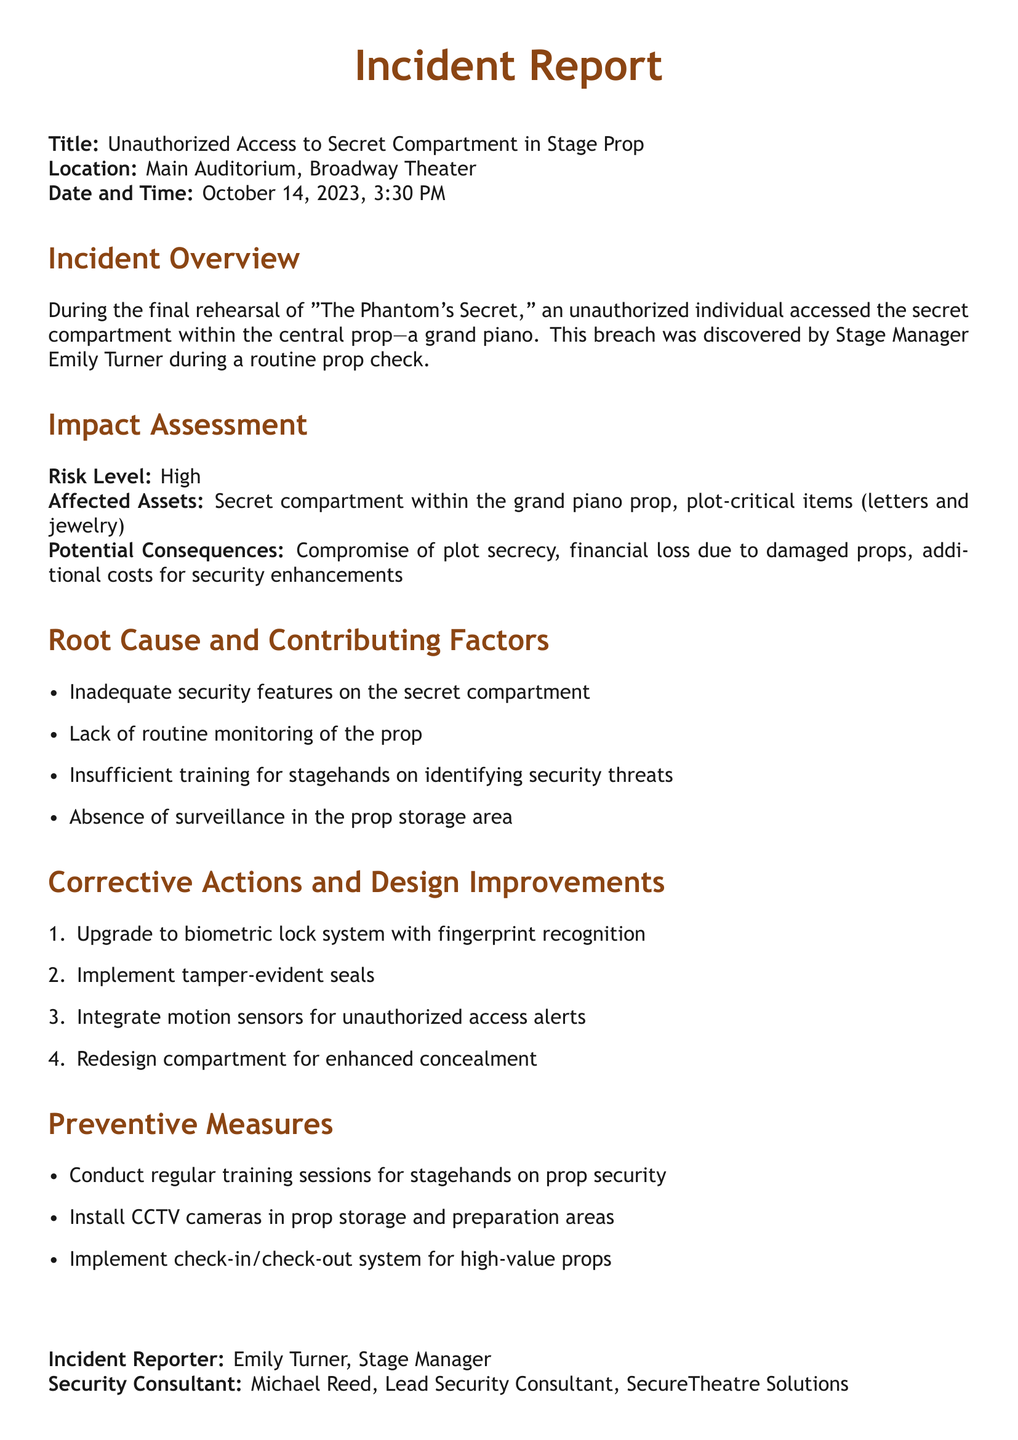what is the title of the incident report? The title of the incident report is mentioned at the top of the document.
Answer: Unauthorized Access to Secret Compartment in Stage Prop who discovered the breach? The incident report specifies that the breach was discovered by the Stage Manager during a routine check.
Answer: Emily Turner what was the location of the incident? The report provides the specific location where the incident occurred.
Answer: Main Auditorium, Broadway Theater what event was taking place during the incident? The document mentions an event associated with the timing of the incident.
Answer: "The Phantom's Secret" what is the risk level assigned to the incident? The report indicates the assessed risk level for the incident.
Answer: High what are two potential consequences mentioned in the report? The document lists several potential consequences related to the incident.
Answer: Compromise of plot secrecy, financial loss name one corrective action proposed in the report. The report contains several corrective actions that are suggested to address the issue.
Answer: Upgrade to biometric lock system what is one preventive measure suggested? The report provides a list of preventive measures to avoid future incidents.
Answer: Conduct regular training sessions for stagehands who was the security consultant for the incident? The document includes the name of the security consultant involved in addressing the breach.
Answer: Michael Reed 